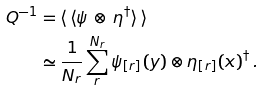Convert formula to latex. <formula><loc_0><loc_0><loc_500><loc_500>Q ^ { - 1 } & = \langle \, \langle \psi \, \otimes \, \eta ^ { \dagger } \rangle \, \rangle \\ & \simeq \frac { 1 } { N _ { r } } \sum _ { r } ^ { N _ { r } } \psi _ { [ r ] } ( y ) \otimes \eta _ { [ r ] } ( x ) ^ { \dag } \, .</formula> 